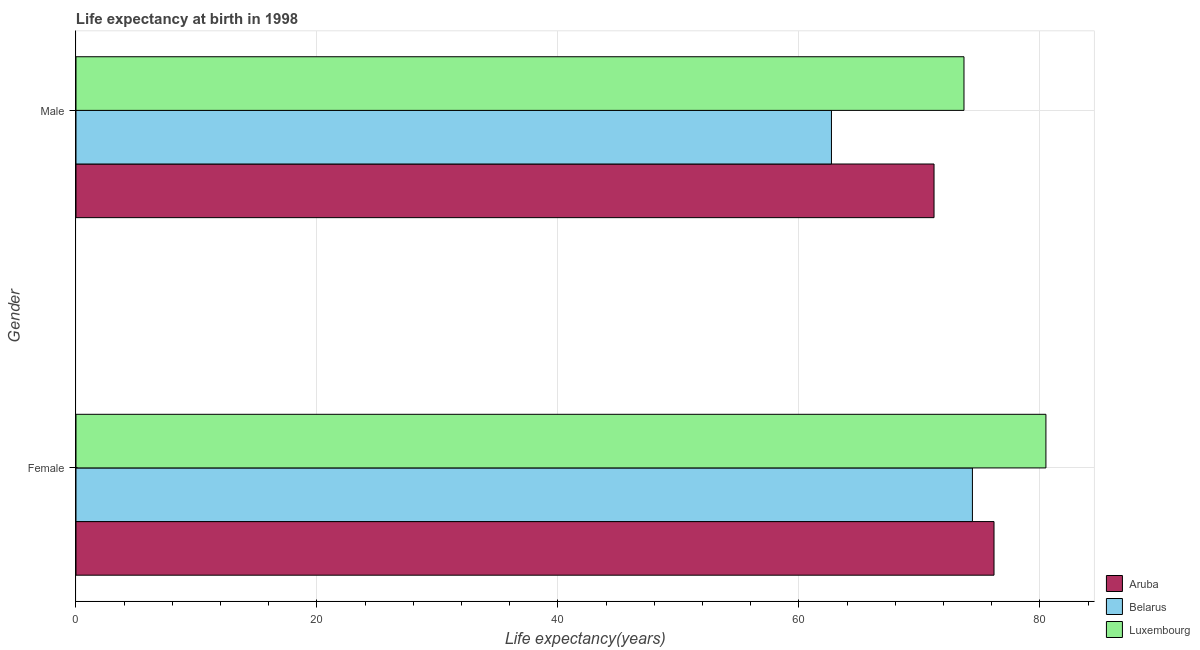How many different coloured bars are there?
Make the answer very short. 3. Are the number of bars per tick equal to the number of legend labels?
Provide a short and direct response. Yes. How many bars are there on the 1st tick from the bottom?
Your response must be concise. 3. What is the label of the 1st group of bars from the top?
Your answer should be compact. Male. What is the life expectancy(male) in Aruba?
Ensure brevity in your answer.  71.21. Across all countries, what is the maximum life expectancy(male)?
Give a very brief answer. 73.7. Across all countries, what is the minimum life expectancy(male)?
Your answer should be very brief. 62.7. In which country was the life expectancy(male) maximum?
Provide a short and direct response. Luxembourg. In which country was the life expectancy(female) minimum?
Ensure brevity in your answer.  Belarus. What is the total life expectancy(female) in the graph?
Give a very brief answer. 231.09. What is the difference between the life expectancy(female) in Aruba and that in Belarus?
Provide a short and direct response. 1.79. What is the difference between the life expectancy(male) in Belarus and the life expectancy(female) in Luxembourg?
Your answer should be very brief. -17.8. What is the average life expectancy(female) per country?
Provide a short and direct response. 77.03. What is the difference between the life expectancy(female) and life expectancy(male) in Aruba?
Your response must be concise. 4.98. What is the ratio of the life expectancy(female) in Belarus to that in Aruba?
Offer a very short reply. 0.98. Is the life expectancy(male) in Belarus less than that in Aruba?
Provide a short and direct response. Yes. What does the 3rd bar from the top in Male represents?
Your answer should be very brief. Aruba. What does the 3rd bar from the bottom in Male represents?
Your response must be concise. Luxembourg. How many bars are there?
Your answer should be compact. 6. Does the graph contain any zero values?
Your answer should be very brief. No. How are the legend labels stacked?
Keep it short and to the point. Vertical. What is the title of the graph?
Provide a short and direct response. Life expectancy at birth in 1998. Does "Singapore" appear as one of the legend labels in the graph?
Keep it short and to the point. No. What is the label or title of the X-axis?
Your response must be concise. Life expectancy(years). What is the Life expectancy(years) in Aruba in Female?
Provide a short and direct response. 76.19. What is the Life expectancy(years) in Belarus in Female?
Provide a short and direct response. 74.4. What is the Life expectancy(years) of Luxembourg in Female?
Make the answer very short. 80.5. What is the Life expectancy(years) in Aruba in Male?
Provide a succinct answer. 71.21. What is the Life expectancy(years) of Belarus in Male?
Provide a short and direct response. 62.7. What is the Life expectancy(years) in Luxembourg in Male?
Provide a succinct answer. 73.7. Across all Gender, what is the maximum Life expectancy(years) of Aruba?
Your answer should be very brief. 76.19. Across all Gender, what is the maximum Life expectancy(years) of Belarus?
Keep it short and to the point. 74.4. Across all Gender, what is the maximum Life expectancy(years) of Luxembourg?
Give a very brief answer. 80.5. Across all Gender, what is the minimum Life expectancy(years) in Aruba?
Your answer should be very brief. 71.21. Across all Gender, what is the minimum Life expectancy(years) of Belarus?
Provide a succinct answer. 62.7. Across all Gender, what is the minimum Life expectancy(years) of Luxembourg?
Ensure brevity in your answer.  73.7. What is the total Life expectancy(years) in Aruba in the graph?
Your answer should be very brief. 147.41. What is the total Life expectancy(years) in Belarus in the graph?
Your response must be concise. 137.1. What is the total Life expectancy(years) in Luxembourg in the graph?
Give a very brief answer. 154.2. What is the difference between the Life expectancy(years) in Aruba in Female and that in Male?
Offer a very short reply. 4.98. What is the difference between the Life expectancy(years) of Belarus in Female and that in Male?
Offer a terse response. 11.7. What is the difference between the Life expectancy(years) of Aruba in Female and the Life expectancy(years) of Belarus in Male?
Provide a succinct answer. 13.49. What is the difference between the Life expectancy(years) of Aruba in Female and the Life expectancy(years) of Luxembourg in Male?
Ensure brevity in your answer.  2.49. What is the difference between the Life expectancy(years) in Belarus in Female and the Life expectancy(years) in Luxembourg in Male?
Your answer should be compact. 0.7. What is the average Life expectancy(years) of Aruba per Gender?
Ensure brevity in your answer.  73.7. What is the average Life expectancy(years) in Belarus per Gender?
Offer a very short reply. 68.55. What is the average Life expectancy(years) of Luxembourg per Gender?
Ensure brevity in your answer.  77.1. What is the difference between the Life expectancy(years) of Aruba and Life expectancy(years) of Belarus in Female?
Offer a terse response. 1.79. What is the difference between the Life expectancy(years) in Aruba and Life expectancy(years) in Luxembourg in Female?
Ensure brevity in your answer.  -4.31. What is the difference between the Life expectancy(years) of Aruba and Life expectancy(years) of Belarus in Male?
Ensure brevity in your answer.  8.51. What is the difference between the Life expectancy(years) in Aruba and Life expectancy(years) in Luxembourg in Male?
Ensure brevity in your answer.  -2.49. What is the difference between the Life expectancy(years) in Belarus and Life expectancy(years) in Luxembourg in Male?
Provide a succinct answer. -11. What is the ratio of the Life expectancy(years) in Aruba in Female to that in Male?
Give a very brief answer. 1.07. What is the ratio of the Life expectancy(years) of Belarus in Female to that in Male?
Ensure brevity in your answer.  1.19. What is the ratio of the Life expectancy(years) of Luxembourg in Female to that in Male?
Ensure brevity in your answer.  1.09. What is the difference between the highest and the second highest Life expectancy(years) of Aruba?
Your answer should be compact. 4.98. What is the difference between the highest and the second highest Life expectancy(years) of Belarus?
Your response must be concise. 11.7. What is the difference between the highest and the second highest Life expectancy(years) of Luxembourg?
Offer a very short reply. 6.8. What is the difference between the highest and the lowest Life expectancy(years) of Aruba?
Your response must be concise. 4.98. 